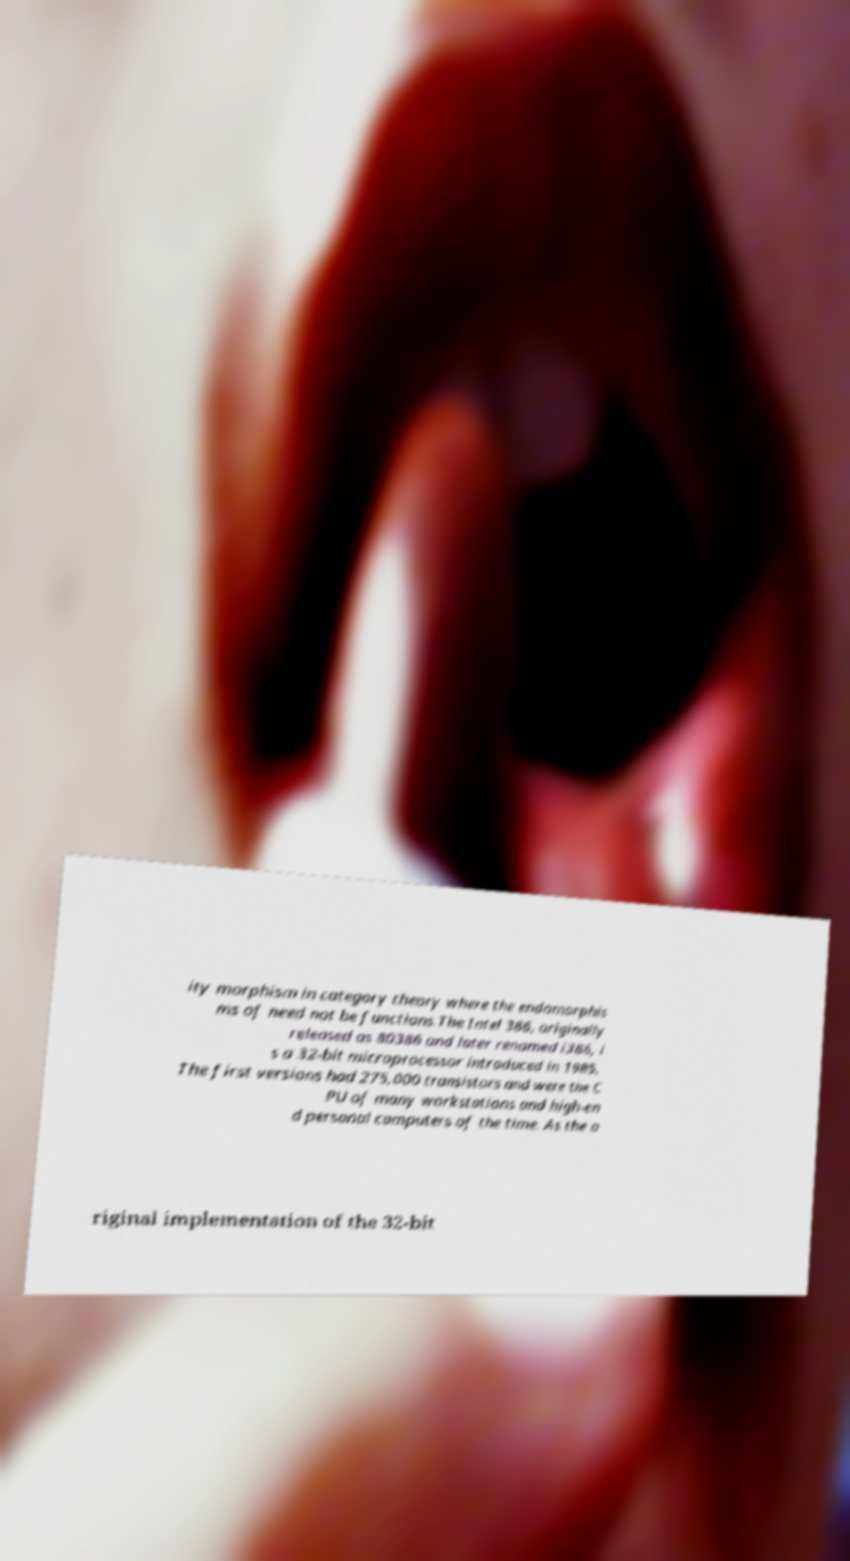Please identify and transcribe the text found in this image. ity morphism in category theory where the endomorphis ms of need not be functions.The Intel 386, originally released as 80386 and later renamed i386, i s a 32-bit microprocessor introduced in 1985. The first versions had 275,000 transistors and were the C PU of many workstations and high-en d personal computers of the time. As the o riginal implementation of the 32-bit 